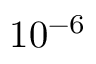Convert formula to latex. <formula><loc_0><loc_0><loc_500><loc_500>1 0 ^ { - 6 }</formula> 